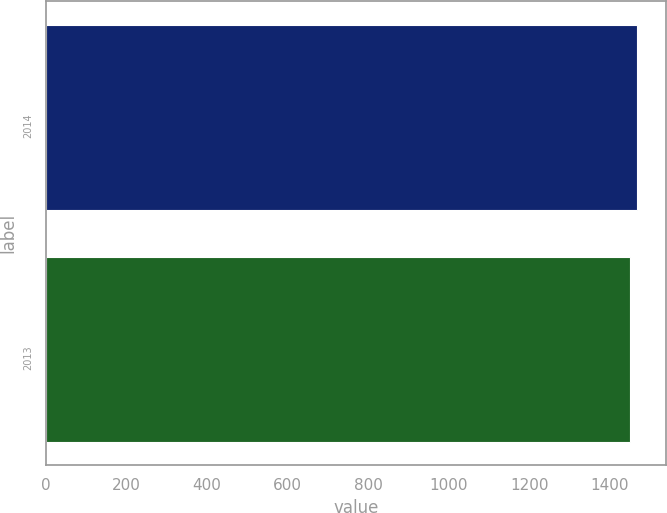Convert chart to OTSL. <chart><loc_0><loc_0><loc_500><loc_500><bar_chart><fcel>2014<fcel>2013<nl><fcel>1468<fcel>1450<nl></chart> 